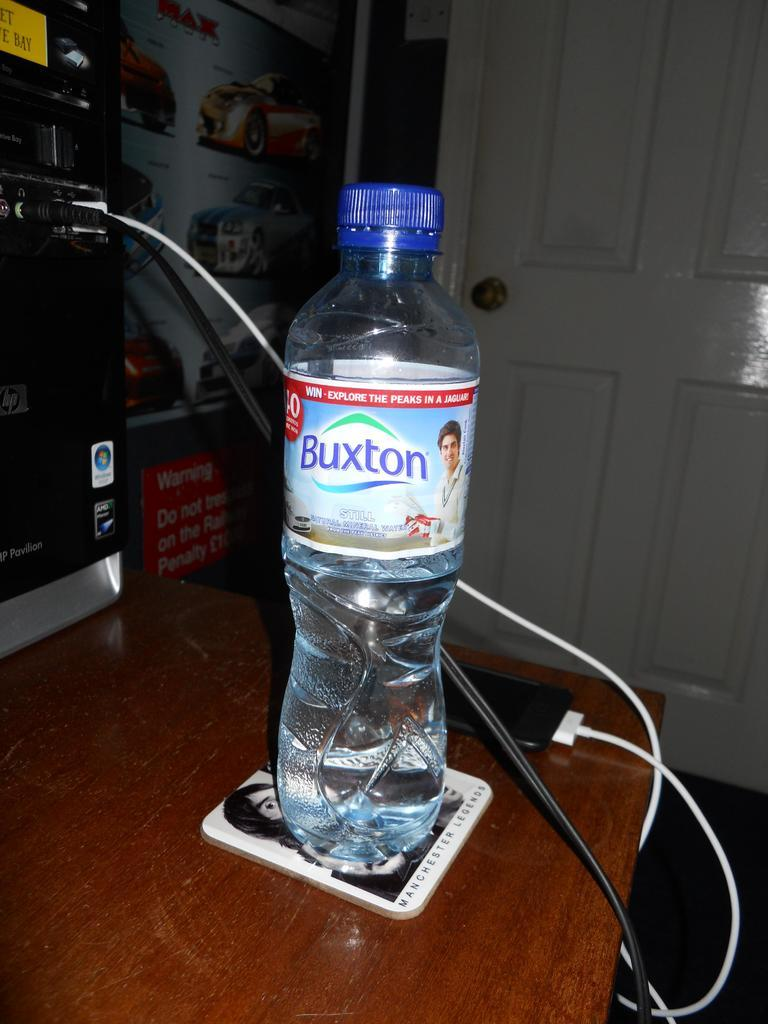<image>
Offer a succinct explanation of the picture presented. A bottle of Buxton sits on a Manchester Legends coaster. 